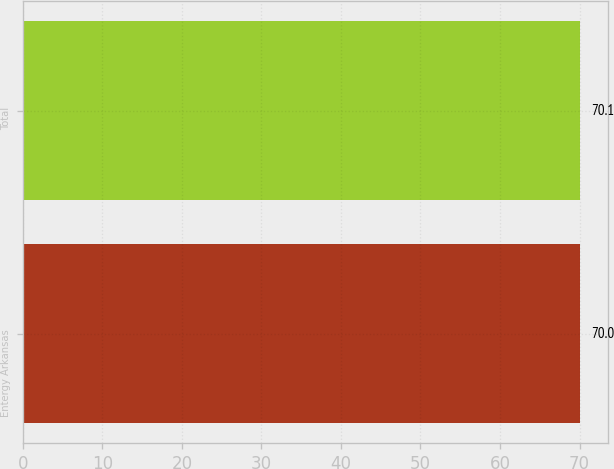<chart> <loc_0><loc_0><loc_500><loc_500><bar_chart><fcel>Entergy Arkansas<fcel>Total<nl><fcel>70<fcel>70.1<nl></chart> 